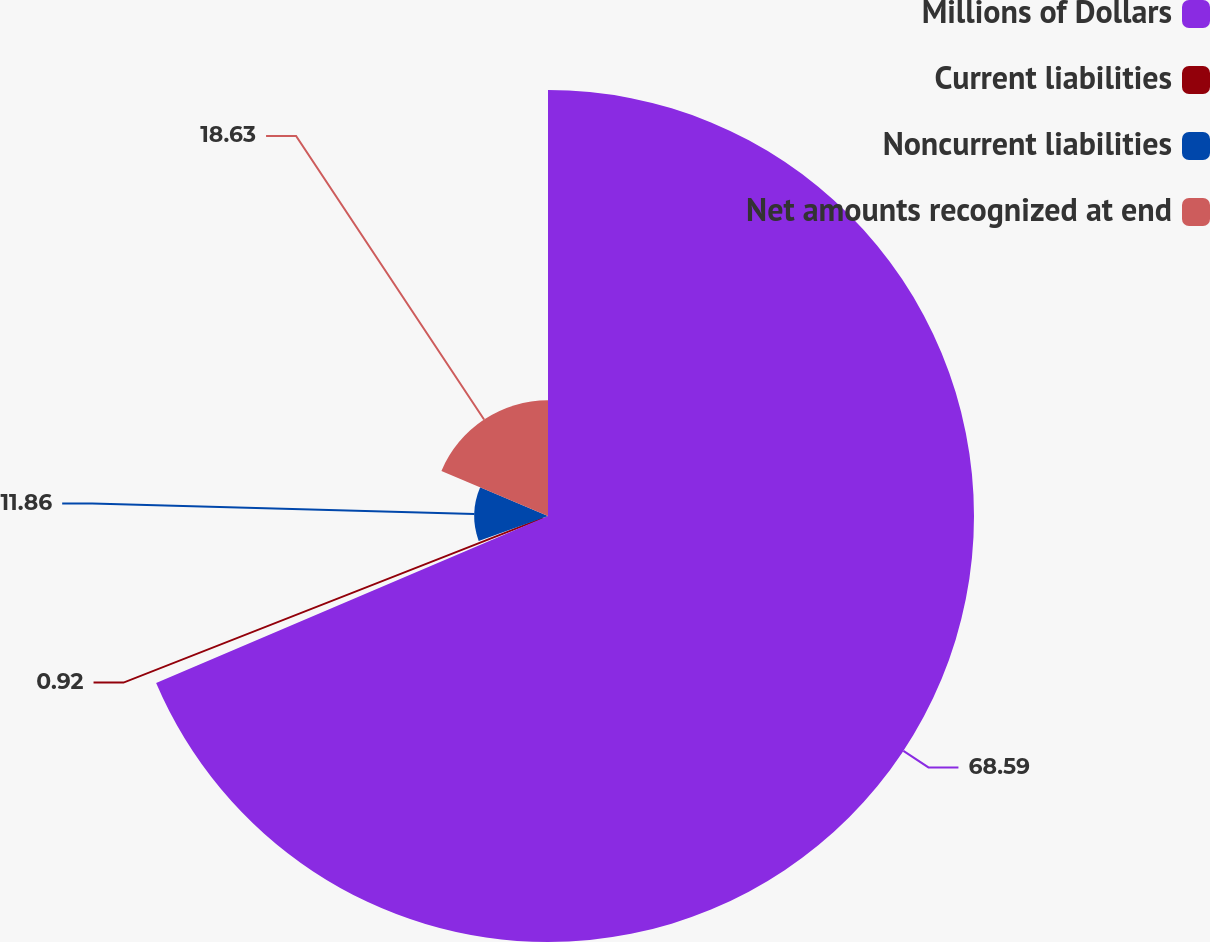Convert chart. <chart><loc_0><loc_0><loc_500><loc_500><pie_chart><fcel>Millions of Dollars<fcel>Current liabilities<fcel>Noncurrent liabilities<fcel>Net amounts recognized at end<nl><fcel>68.58%<fcel>0.92%<fcel>11.86%<fcel>18.63%<nl></chart> 